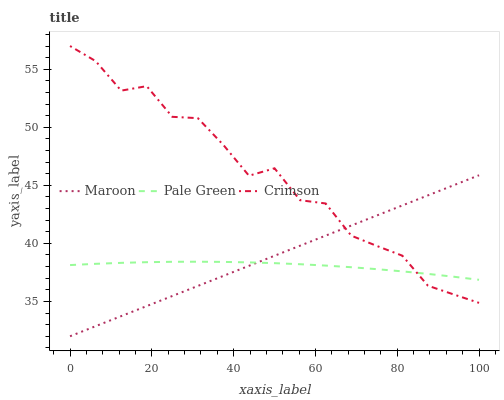Does Pale Green have the minimum area under the curve?
Answer yes or no. Yes. Does Crimson have the maximum area under the curve?
Answer yes or no. Yes. Does Maroon have the minimum area under the curve?
Answer yes or no. No. Does Maroon have the maximum area under the curve?
Answer yes or no. No. Is Maroon the smoothest?
Answer yes or no. Yes. Is Crimson the roughest?
Answer yes or no. Yes. Is Pale Green the smoothest?
Answer yes or no. No. Is Pale Green the roughest?
Answer yes or no. No. Does Pale Green have the lowest value?
Answer yes or no. No. Does Crimson have the highest value?
Answer yes or no. Yes. Does Maroon have the highest value?
Answer yes or no. No. Does Crimson intersect Maroon?
Answer yes or no. Yes. Is Crimson less than Maroon?
Answer yes or no. No. Is Crimson greater than Maroon?
Answer yes or no. No. 